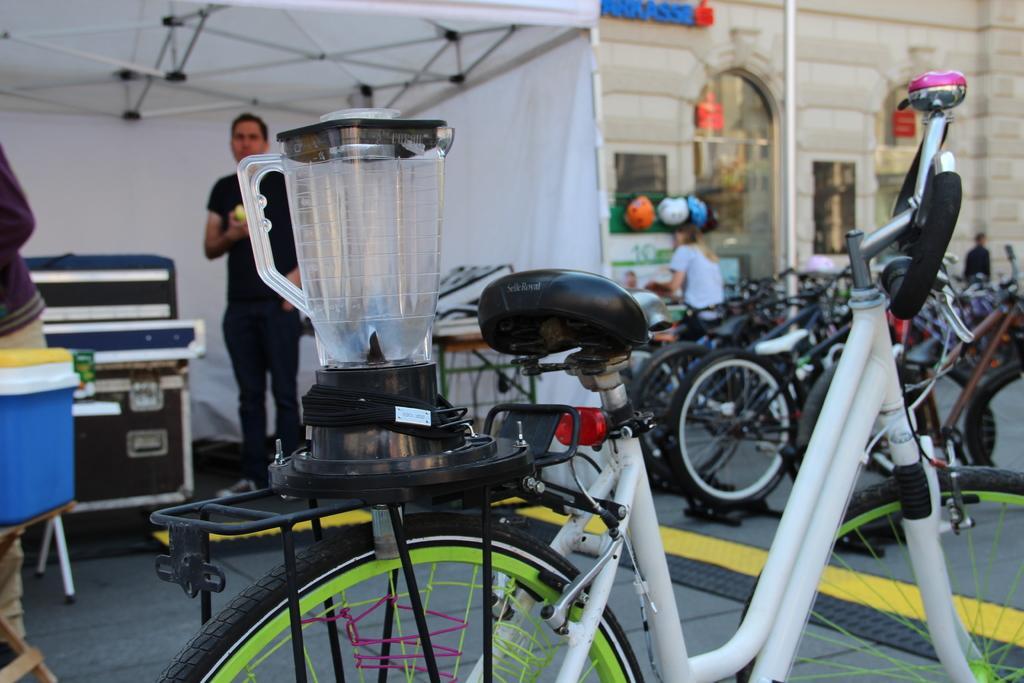Please provide a concise description of this image. In this image, we can see a mixer grinder on the cycle. There is a person wearing clothes and standing inside the tent. There are some boxes on the left side of the image. There are some cycles in front of the building. 